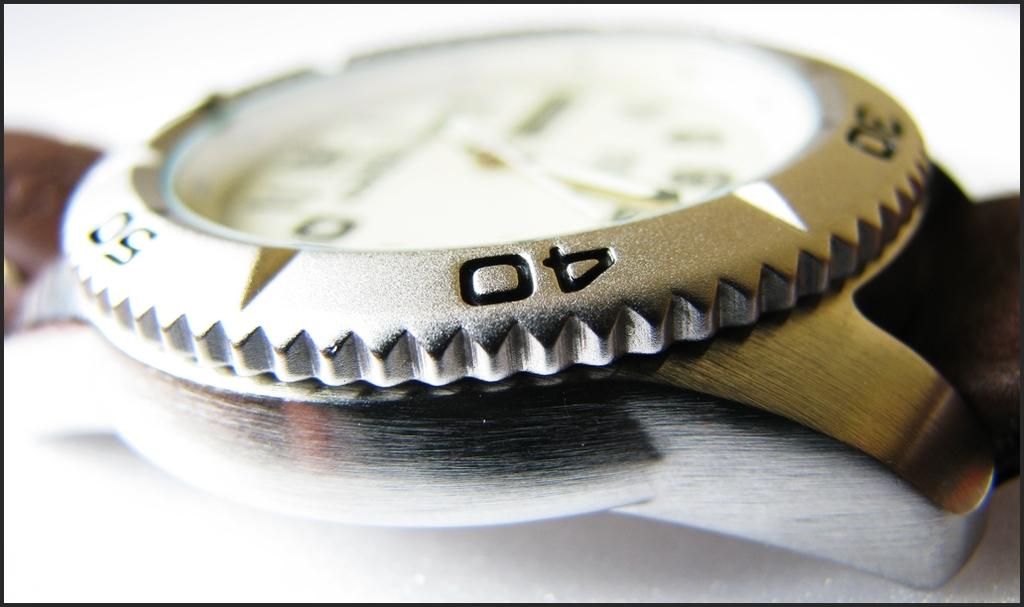What number is shown in focus on this watch?
Ensure brevity in your answer.  40. 